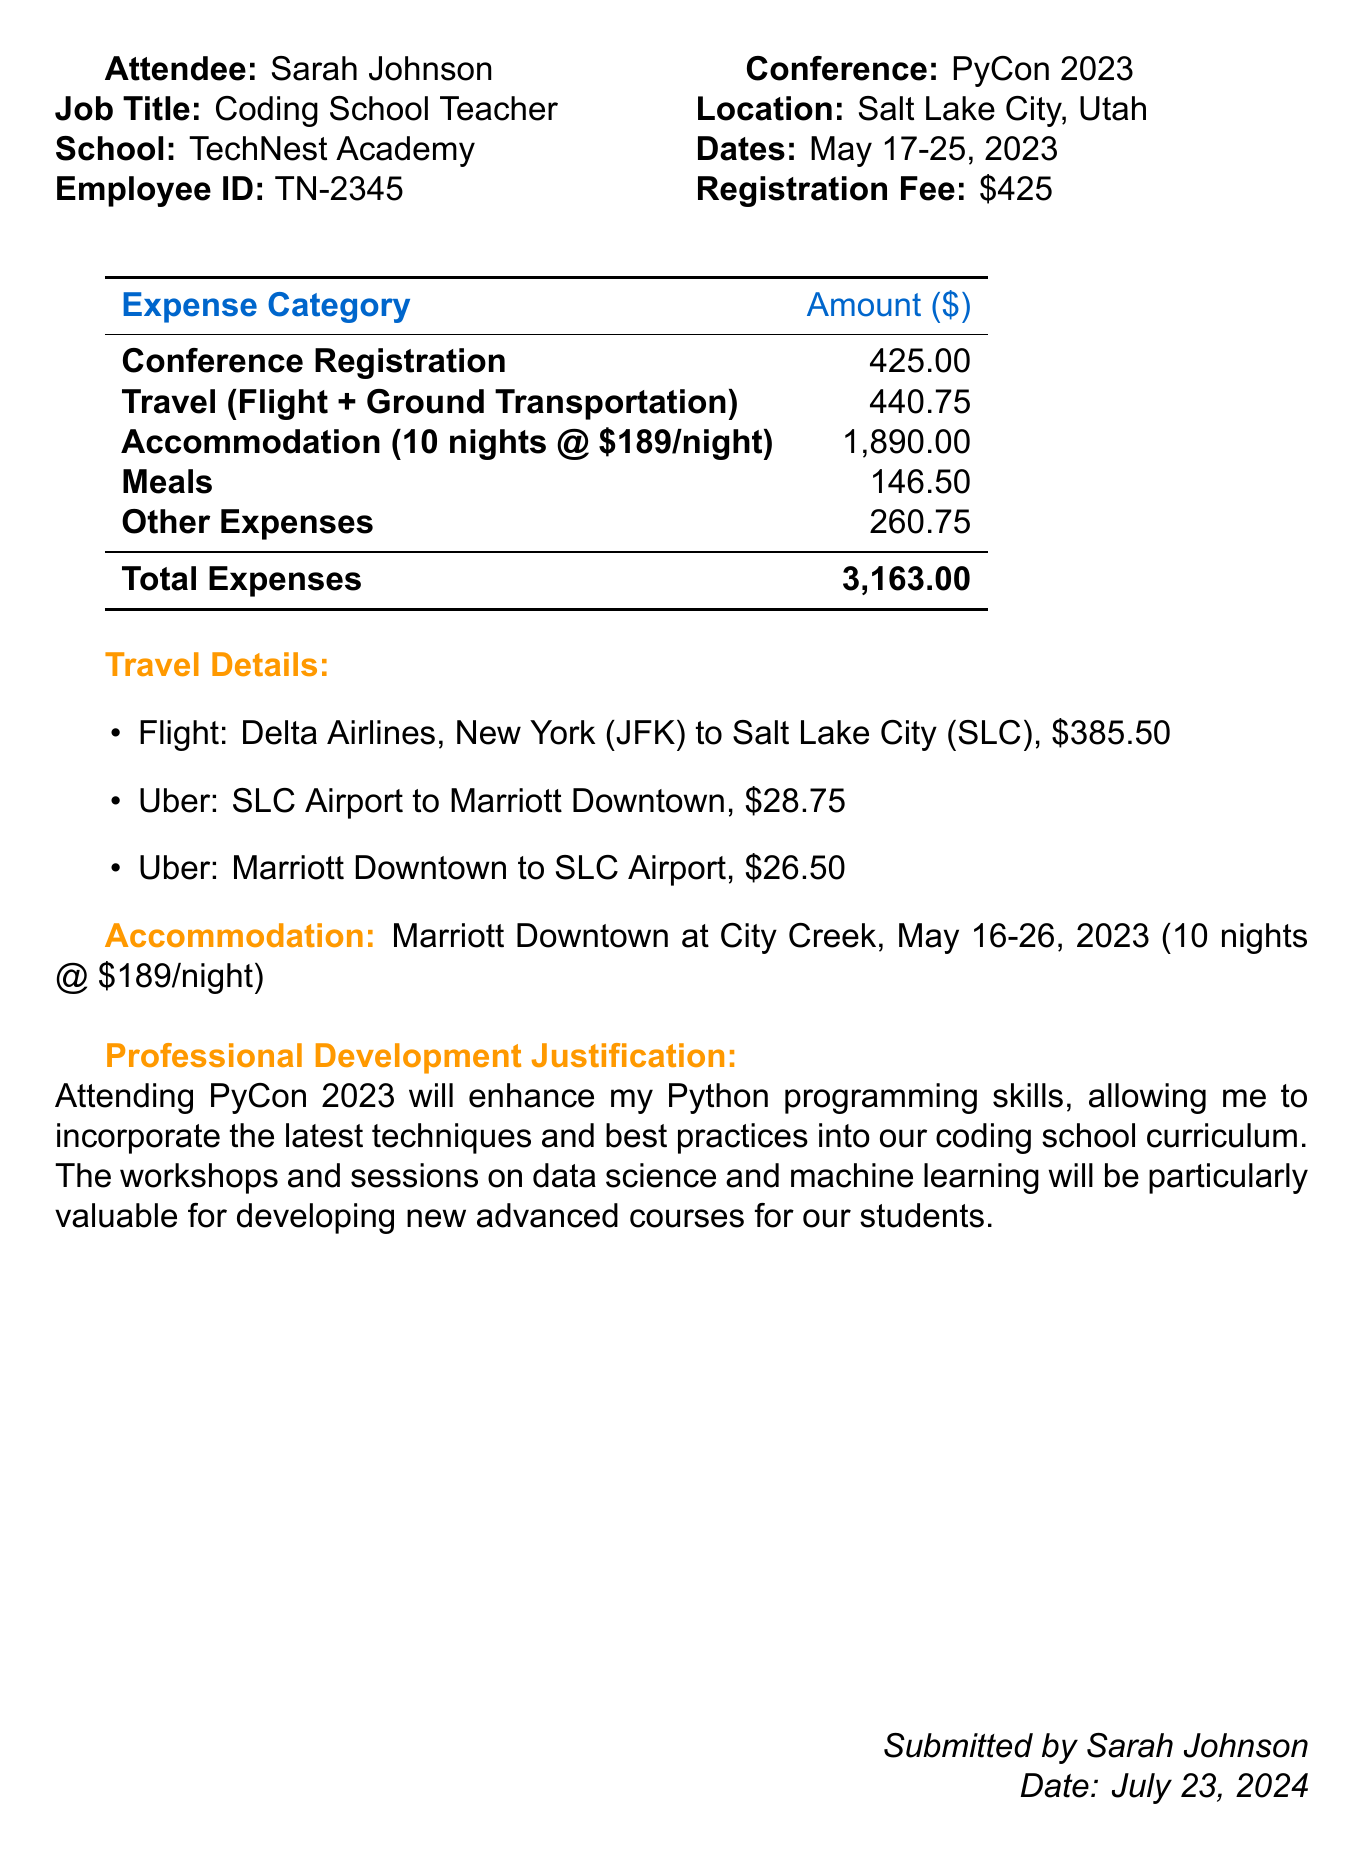What is the name of the conference? The document specifies the conference as "PyCon 2023".
Answer: PyCon 2023 What is the total cost of accommodation? The accommodation cost is clearly stated as $1890 for 10 nights at a rate of $189 per night.
Answer: $1890 Who submitted the expense report? The document indicates that the expense report was submitted by Sarah Johnson.
Answer: Sarah Johnson How much was spent on meals? The total amount spent on meals is provided as $146.50.
Answer: $146.50 What is the cost of the flight? The cost of the flight from New York to Salt Lake City is specifically mentioned as $385.50.
Answer: $385.50 How many nights did Sarah stay at the hotel? The document states she stayed for 10 nights during the conference.
Answer: 10 What is the registration fee for the conference? The registration fee is stated as a specific amount of $425.
Answer: $425 What is the justification for attending the conference? The provided justification highlights the enhancement of Python programming skills to improve the curriculum.
Answer: Enhance Python programming skills What type of ground transportation was used from the airport? The document lists Uber as the mode of ground transportation from the airport to the hotel.
Answer: Uber 